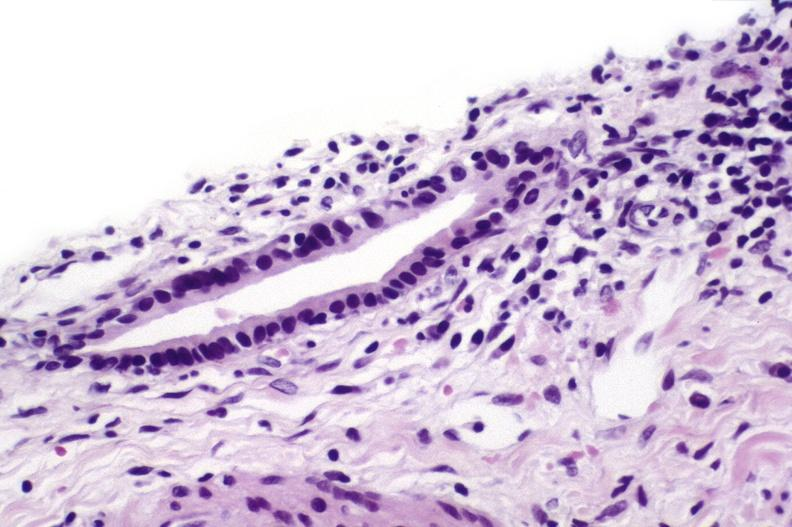does 70yof show sarcoid?
Answer the question using a single word or phrase. No 